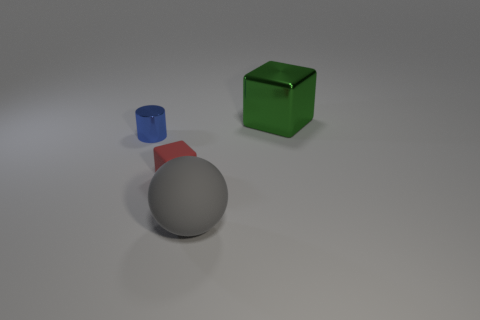Add 2 small blue objects. How many objects exist? 6 Subtract all balls. How many objects are left? 3 Subtract all large green shiny cubes. Subtract all small rubber blocks. How many objects are left? 2 Add 3 big gray balls. How many big gray balls are left? 4 Add 3 tiny matte things. How many tiny matte things exist? 4 Subtract 0 yellow spheres. How many objects are left? 4 